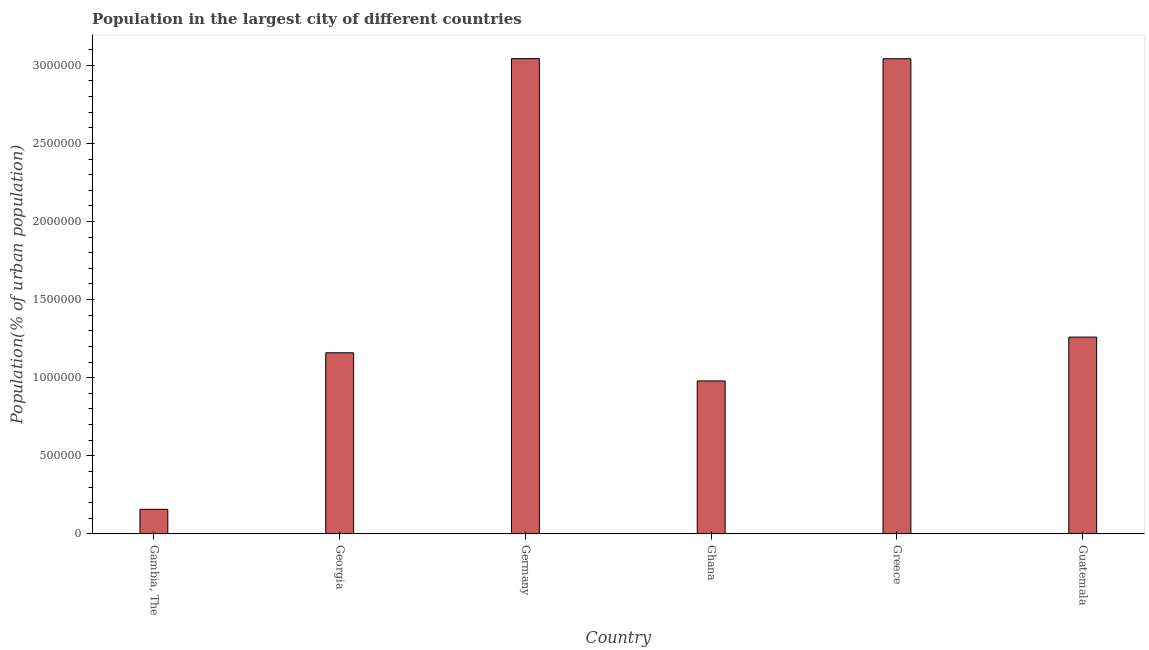Does the graph contain grids?
Provide a short and direct response. No. What is the title of the graph?
Your answer should be very brief. Population in the largest city of different countries. What is the label or title of the Y-axis?
Give a very brief answer. Population(% of urban population). What is the population in largest city in Gambia, The?
Your answer should be very brief. 1.57e+05. Across all countries, what is the maximum population in largest city?
Give a very brief answer. 3.04e+06. Across all countries, what is the minimum population in largest city?
Your response must be concise. 1.57e+05. In which country was the population in largest city minimum?
Keep it short and to the point. Gambia, The. What is the sum of the population in largest city?
Offer a terse response. 9.64e+06. What is the difference between the population in largest city in Ghana and Guatemala?
Make the answer very short. -2.81e+05. What is the average population in largest city per country?
Give a very brief answer. 1.61e+06. What is the median population in largest city?
Your answer should be compact. 1.21e+06. What is the ratio of the population in largest city in Gambia, The to that in Ghana?
Your response must be concise. 0.16. What is the difference between the highest and the second highest population in largest city?
Give a very brief answer. 640. What is the difference between the highest and the lowest population in largest city?
Offer a very short reply. 2.89e+06. In how many countries, is the population in largest city greater than the average population in largest city taken over all countries?
Give a very brief answer. 2. How many bars are there?
Your response must be concise. 6. What is the Population(% of urban population) of Gambia, The?
Give a very brief answer. 1.57e+05. What is the Population(% of urban population) of Georgia?
Offer a terse response. 1.16e+06. What is the Population(% of urban population) of Germany?
Offer a very short reply. 3.04e+06. What is the Population(% of urban population) in Ghana?
Provide a succinct answer. 9.79e+05. What is the Population(% of urban population) of Greece?
Offer a terse response. 3.04e+06. What is the Population(% of urban population) of Guatemala?
Offer a very short reply. 1.26e+06. What is the difference between the Population(% of urban population) in Gambia, The and Georgia?
Your response must be concise. -1.00e+06. What is the difference between the Population(% of urban population) in Gambia, The and Germany?
Your response must be concise. -2.89e+06. What is the difference between the Population(% of urban population) in Gambia, The and Ghana?
Provide a succinct answer. -8.22e+05. What is the difference between the Population(% of urban population) in Gambia, The and Greece?
Ensure brevity in your answer.  -2.89e+06. What is the difference between the Population(% of urban population) in Gambia, The and Guatemala?
Ensure brevity in your answer.  -1.10e+06. What is the difference between the Population(% of urban population) in Georgia and Germany?
Your response must be concise. -1.88e+06. What is the difference between the Population(% of urban population) in Georgia and Ghana?
Ensure brevity in your answer.  1.80e+05. What is the difference between the Population(% of urban population) in Georgia and Greece?
Your answer should be very brief. -1.88e+06. What is the difference between the Population(% of urban population) in Georgia and Guatemala?
Keep it short and to the point. -1.00e+05. What is the difference between the Population(% of urban population) in Germany and Ghana?
Your answer should be very brief. 2.06e+06. What is the difference between the Population(% of urban population) in Germany and Greece?
Your answer should be compact. 640. What is the difference between the Population(% of urban population) in Germany and Guatemala?
Provide a short and direct response. 1.78e+06. What is the difference between the Population(% of urban population) in Ghana and Greece?
Your answer should be compact. -2.06e+06. What is the difference between the Population(% of urban population) in Ghana and Guatemala?
Offer a terse response. -2.81e+05. What is the difference between the Population(% of urban population) in Greece and Guatemala?
Provide a succinct answer. 1.78e+06. What is the ratio of the Population(% of urban population) in Gambia, The to that in Georgia?
Make the answer very short. 0.14. What is the ratio of the Population(% of urban population) in Gambia, The to that in Germany?
Your answer should be compact. 0.05. What is the ratio of the Population(% of urban population) in Gambia, The to that in Ghana?
Make the answer very short. 0.16. What is the ratio of the Population(% of urban population) in Gambia, The to that in Greece?
Keep it short and to the point. 0.05. What is the ratio of the Population(% of urban population) in Georgia to that in Germany?
Provide a short and direct response. 0.38. What is the ratio of the Population(% of urban population) in Georgia to that in Ghana?
Keep it short and to the point. 1.18. What is the ratio of the Population(% of urban population) in Georgia to that in Greece?
Your answer should be compact. 0.38. What is the ratio of the Population(% of urban population) in Georgia to that in Guatemala?
Give a very brief answer. 0.92. What is the ratio of the Population(% of urban population) in Germany to that in Ghana?
Your response must be concise. 3.11. What is the ratio of the Population(% of urban population) in Germany to that in Greece?
Offer a terse response. 1. What is the ratio of the Population(% of urban population) in Germany to that in Guatemala?
Offer a very short reply. 2.42. What is the ratio of the Population(% of urban population) in Ghana to that in Greece?
Offer a terse response. 0.32. What is the ratio of the Population(% of urban population) in Ghana to that in Guatemala?
Offer a very short reply. 0.78. What is the ratio of the Population(% of urban population) in Greece to that in Guatemala?
Make the answer very short. 2.42. 